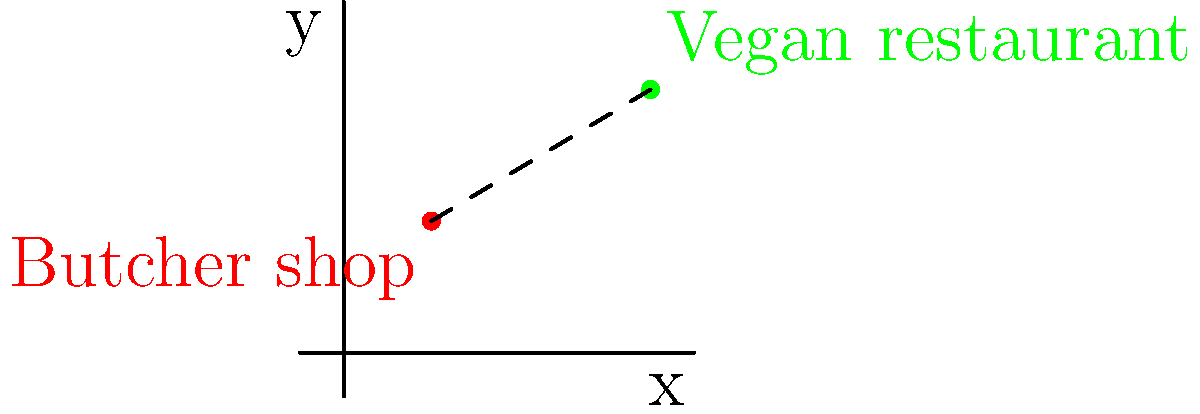On a coordinate plane, a butcher shop is located at (2, 3) and a vegan restaurant is located at (7, 6). Calculate the straight-line distance between these two locations to determine the minimum distance an activist would need to travel to spread awareness about plant-based alternatives. To find the distance between two points on a coordinate plane, we can use the distance formula:

$$d = \sqrt{(x_2 - x_1)^2 + (y_2 - y_1)^2}$$

Where $(x_1, y_1)$ is the coordinates of the first point (butcher shop) and $(x_2, y_2)$ is the coordinates of the second point (vegan restaurant).

Step 1: Identify the coordinates
Butcher shop: $(x_1, y_1) = (2, 3)$
Vegan restaurant: $(x_2, y_2) = (7, 6)$

Step 2: Substitute the values into the distance formula
$$d = \sqrt{(7 - 2)^2 + (6 - 3)^2}$$

Step 3: Simplify the expressions inside the parentheses
$$d = \sqrt{5^2 + 3^2}$$

Step 4: Calculate the squares
$$d = \sqrt{25 + 9}$$

Step 5: Add the values under the square root
$$d = \sqrt{34}$$

Step 6: Simplify the square root (optional)
$$d = \sqrt{34} \approx 5.83$$

Therefore, the straight-line distance between the butcher shop and the vegan restaurant is $\sqrt{34}$ units, or approximately 5.83 units.
Answer: $\sqrt{34}$ units 